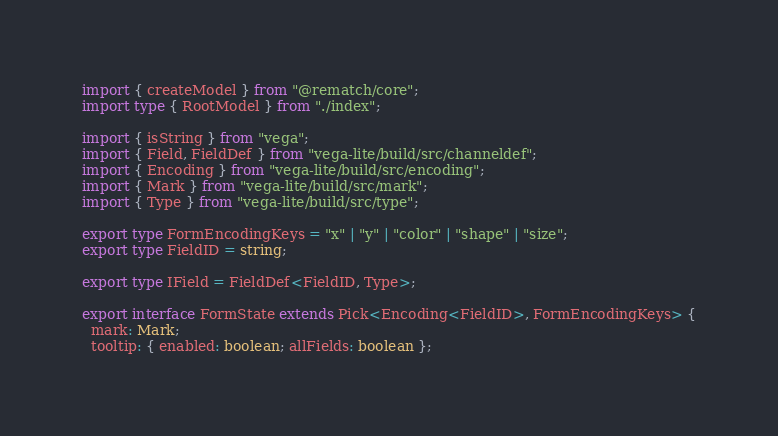<code> <loc_0><loc_0><loc_500><loc_500><_TypeScript_>import { createModel } from "@rematch/core";
import type { RootModel } from "./index";

import { isString } from "vega";
import { Field, FieldDef } from "vega-lite/build/src/channeldef";
import { Encoding } from "vega-lite/build/src/encoding";
import { Mark } from "vega-lite/build/src/mark";
import { Type } from "vega-lite/build/src/type";

export type FormEncodingKeys = "x" | "y" | "color" | "shape" | "size";
export type FieldID = string;

export type IField = FieldDef<FieldID, Type>;

export interface FormState extends Pick<Encoding<FieldID>, FormEncodingKeys> {
  mark: Mark;
  tooltip: { enabled: boolean; allFields: boolean };
</code> 